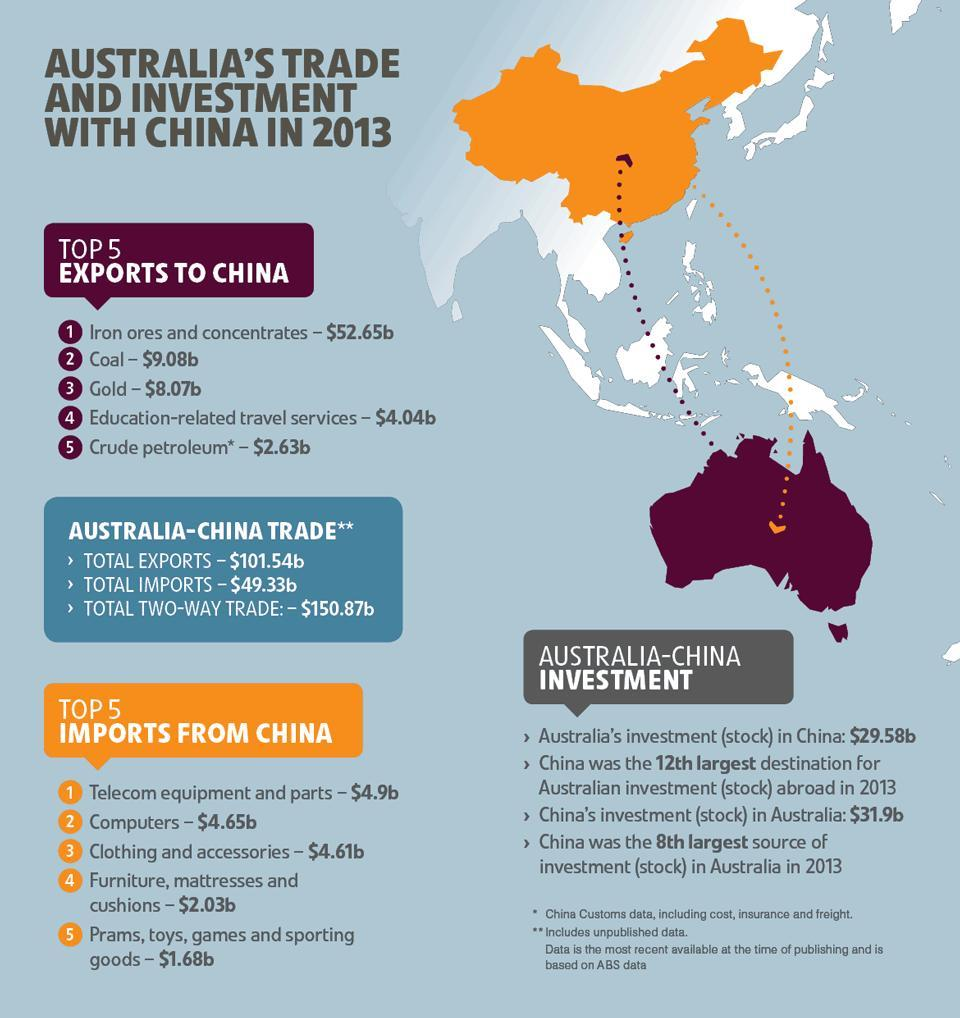what is the total of the 2nd and 3rd import from China
Answer the question with a short phrase. 9.26 how much was the value of item 5 less than item 3 in imports from china 2.93 How much is the value of export more than the value of imports 52.21 what is the total value of gold and coal export 17.15 what colour is the map of australia, purple or orange purple 